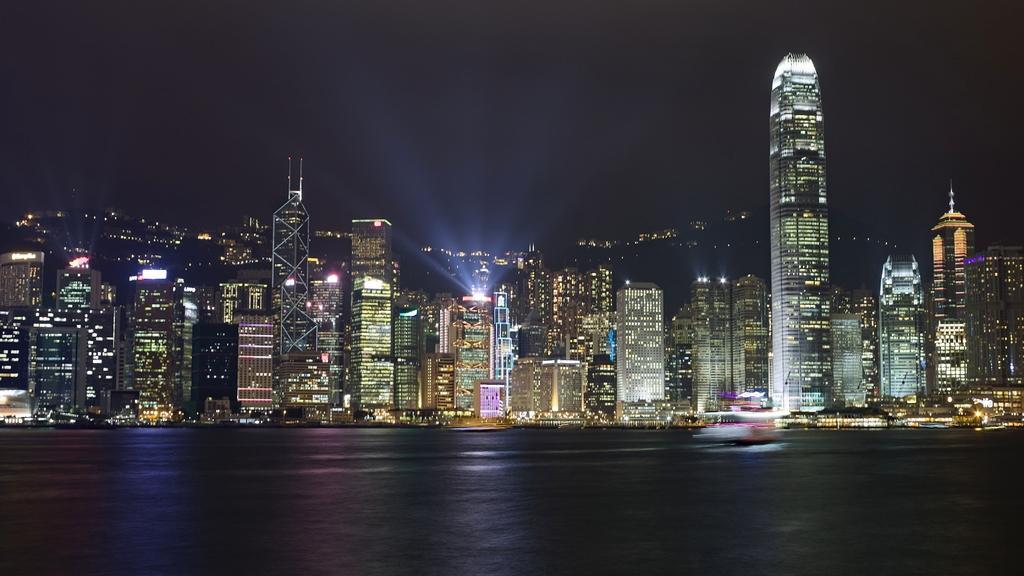Could you give a brief overview of what you see in this image? In this picture there are buildings in the background. In the front there is water. 